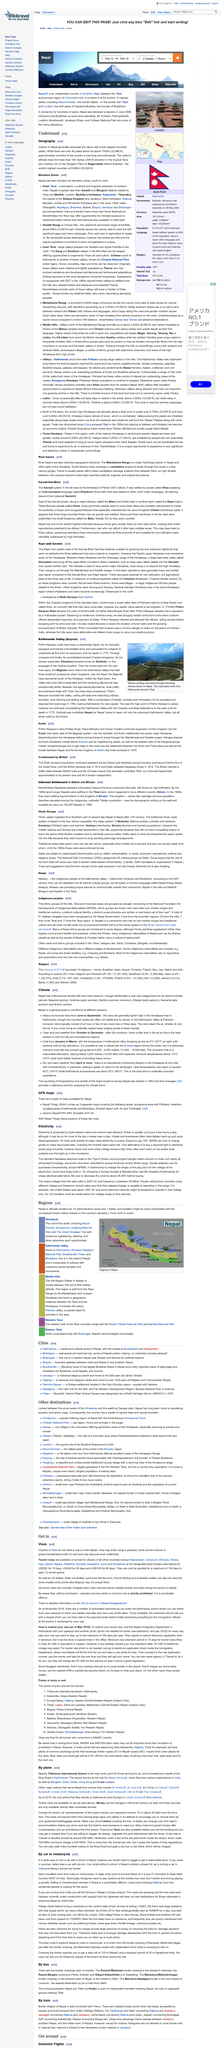Give some essential details in this illustration. Citizens of India are not required to obtain a visa when entering Nepal. I am a computer program, and therefore do not have the ability to pay for or obtain visas. I can provide information on the cost of a tourist visa for 90 days, which is USD100. In 1769, Prithvi Narayan made Kathmandu his new capital after deposing the local kings. The Karnali system is the birthplace of Pahari culture, as stated in historical records. India is located to the south of Tibet, China. 